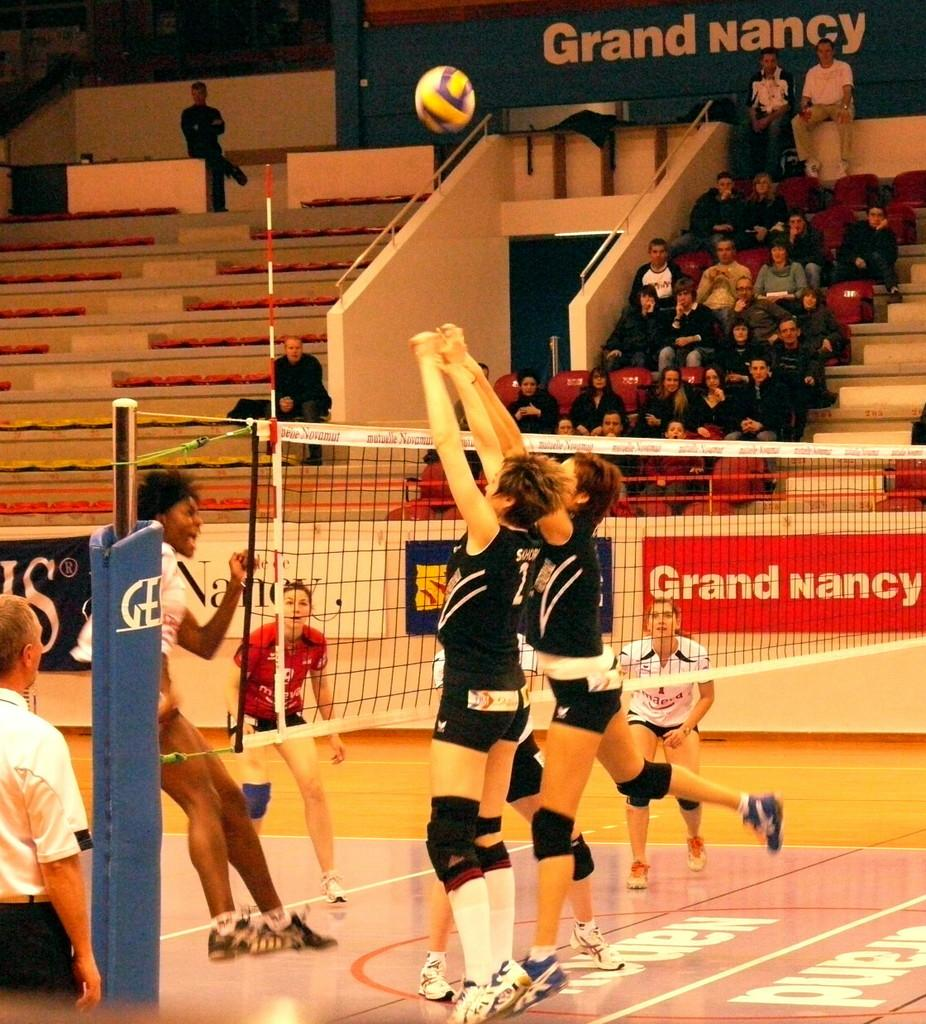<image>
Share a concise interpretation of the image provided. two volleyball teams on a court, with Grand Nancy having a sponsorship slot 